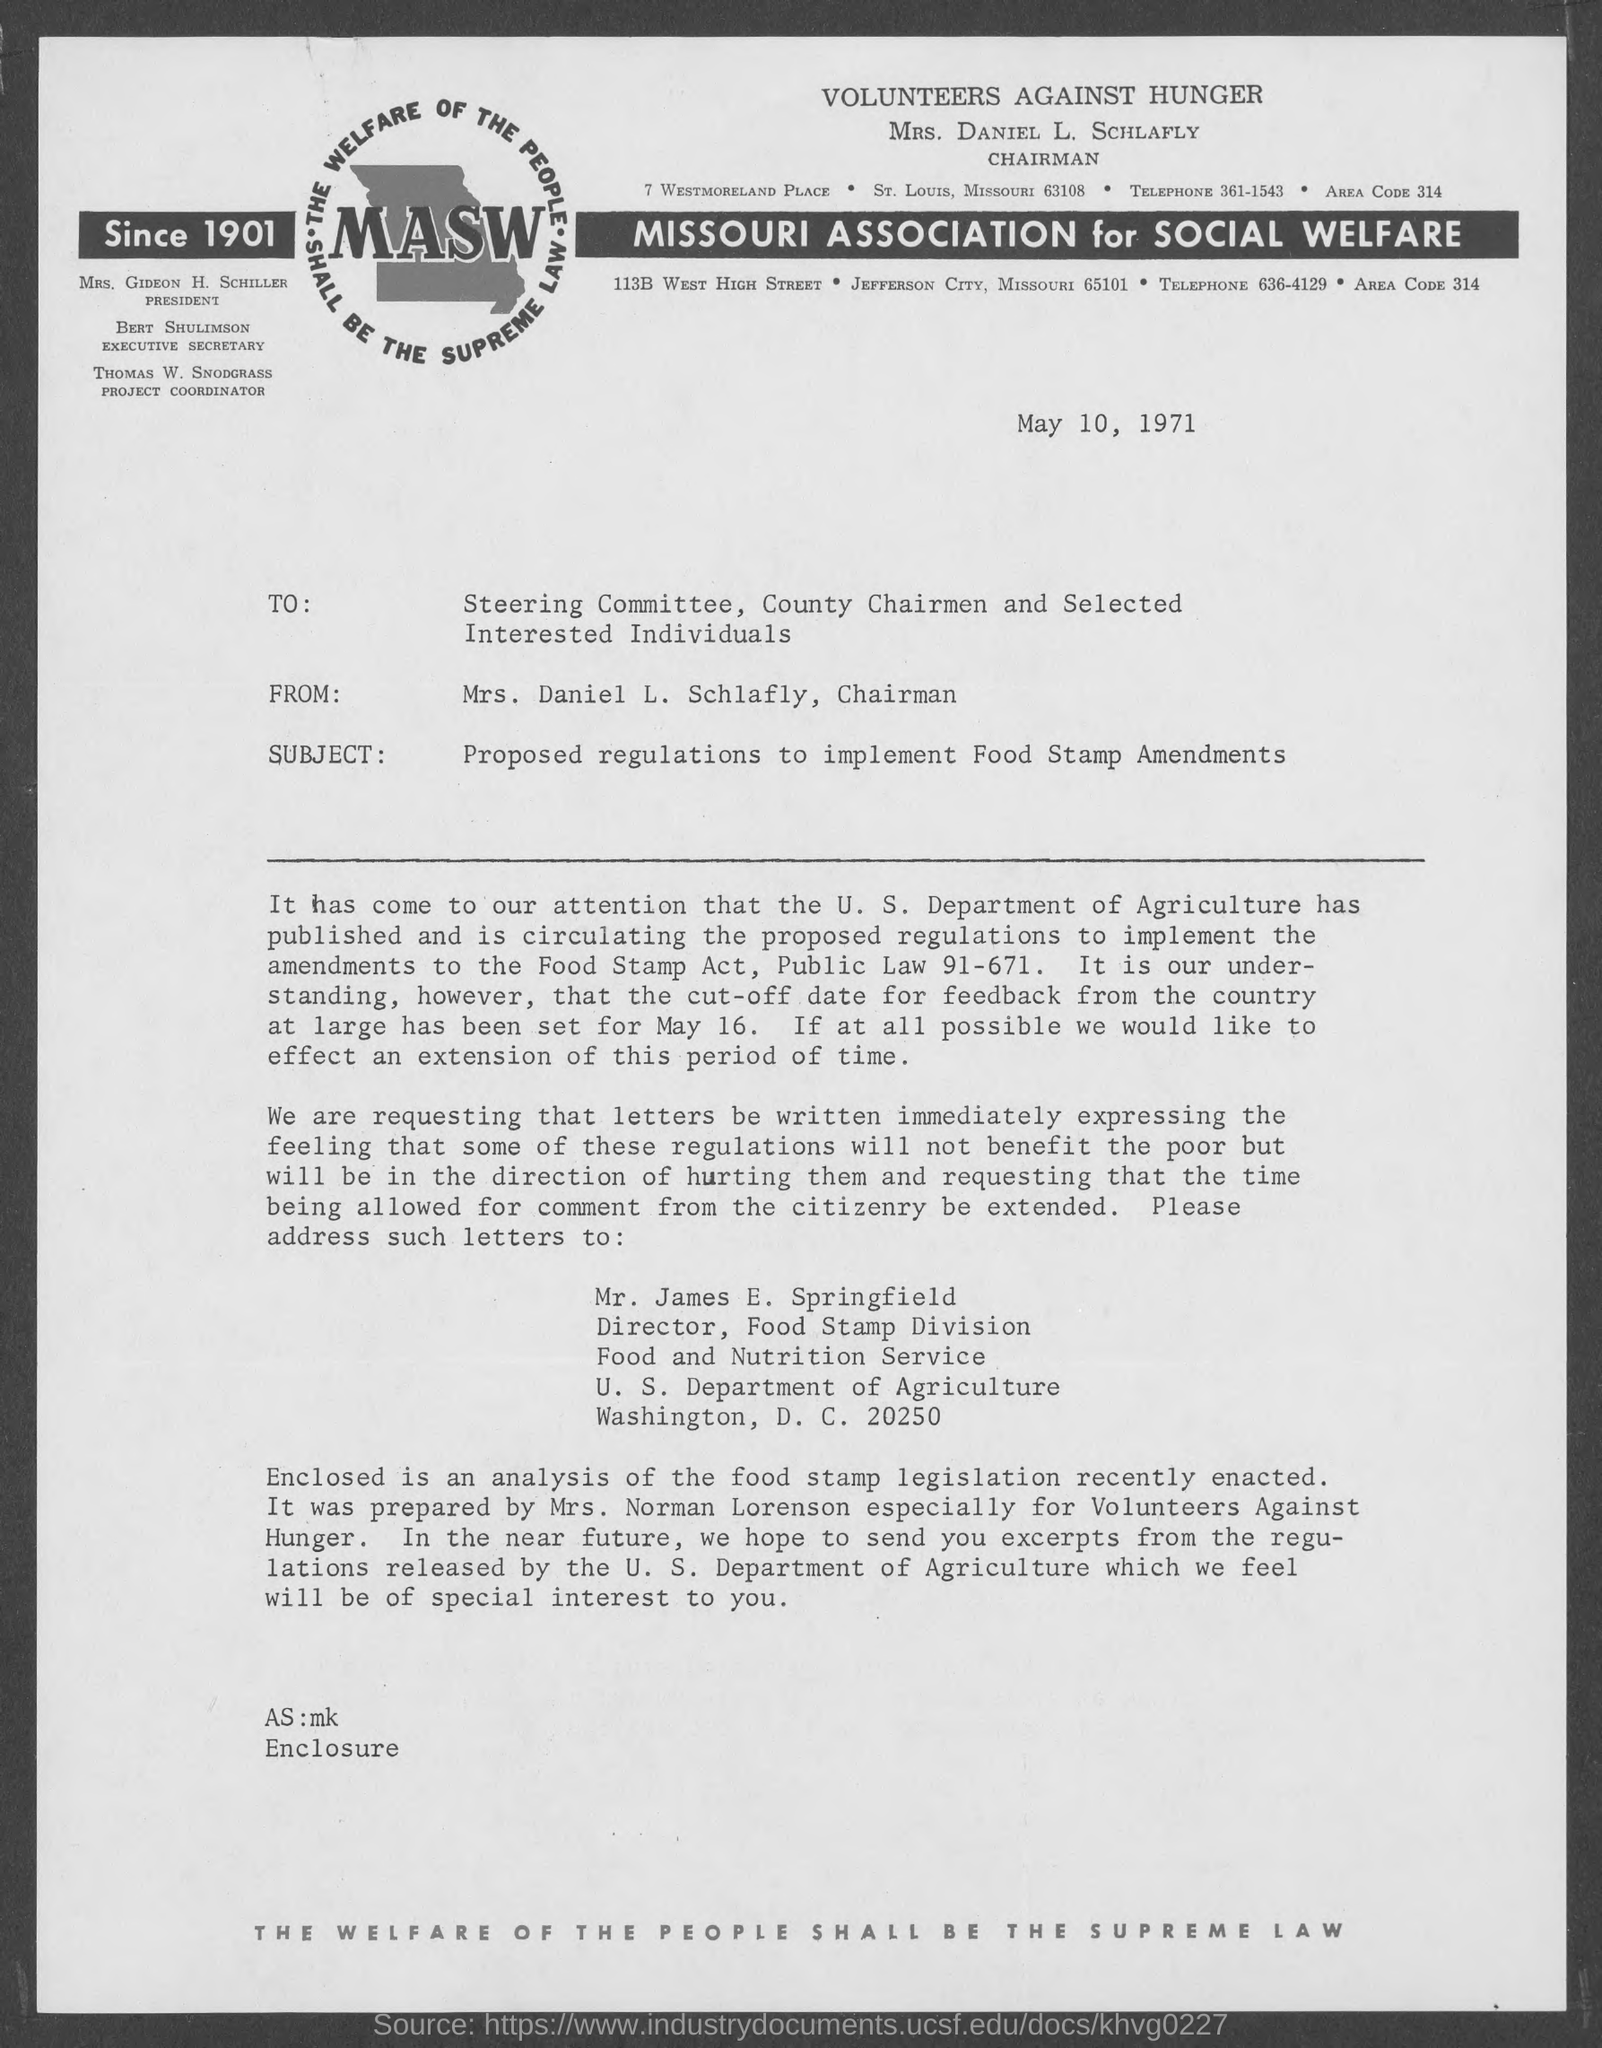What is the position of mrs. gideon h. schiller ?
Give a very brief answer. President. What is the position of bert shulimson ?
Keep it short and to the point. Executive Secretary. What is the position of thomas w. snodgrass ?
Your response must be concise. Project Coordinator. What is the position of mrs. daniel l. schlafly ?
Offer a very short reply. Chairman. 